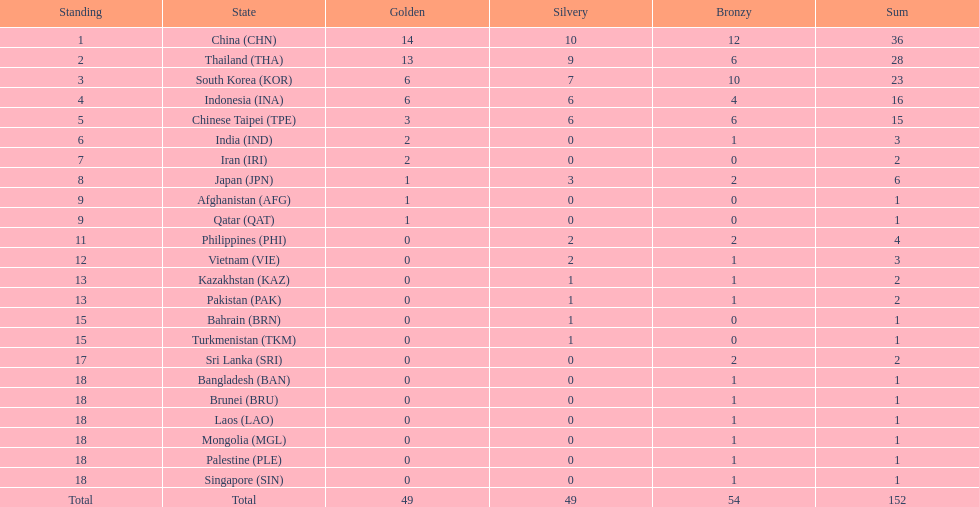How many combined silver medals did china, india, and japan earn ? 13. 